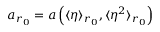Convert formula to latex. <formula><loc_0><loc_0><loc_500><loc_500>a _ { r _ { 0 } } = a \left ( \langle \eta \rangle _ { r _ { 0 } } , \langle \eta ^ { 2 } \rangle _ { r _ { 0 } } \right )</formula> 